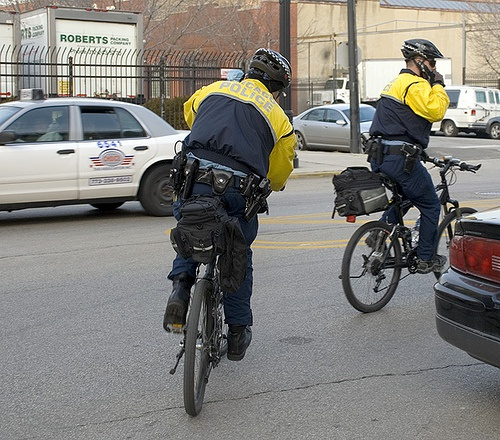Describe the objects in this image and their specific colors. I can see people in lightgray, black, gray, and darkblue tones, car in lightgray, darkgray, black, and gray tones, truck in lightgray, ivory, darkgray, gray, and black tones, people in lightgray, black, gray, and khaki tones, and car in lightgray, black, maroon, gray, and darkgray tones in this image. 